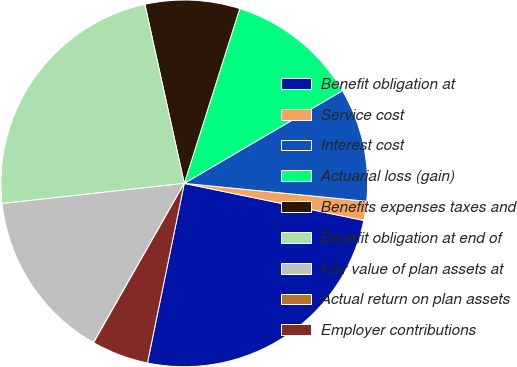<chart> <loc_0><loc_0><loc_500><loc_500><pie_chart><fcel>Benefit obligation at<fcel>Service cost<fcel>Interest cost<fcel>Actuarial loss (gain)<fcel>Benefits expenses taxes and<fcel>Benefit obligation at end of<fcel>Fair value of plan assets at<fcel>Actual return on plan assets<fcel>Employer contributions<nl><fcel>24.98%<fcel>1.68%<fcel>10.0%<fcel>11.67%<fcel>8.34%<fcel>23.31%<fcel>14.99%<fcel>0.02%<fcel>5.01%<nl></chart> 